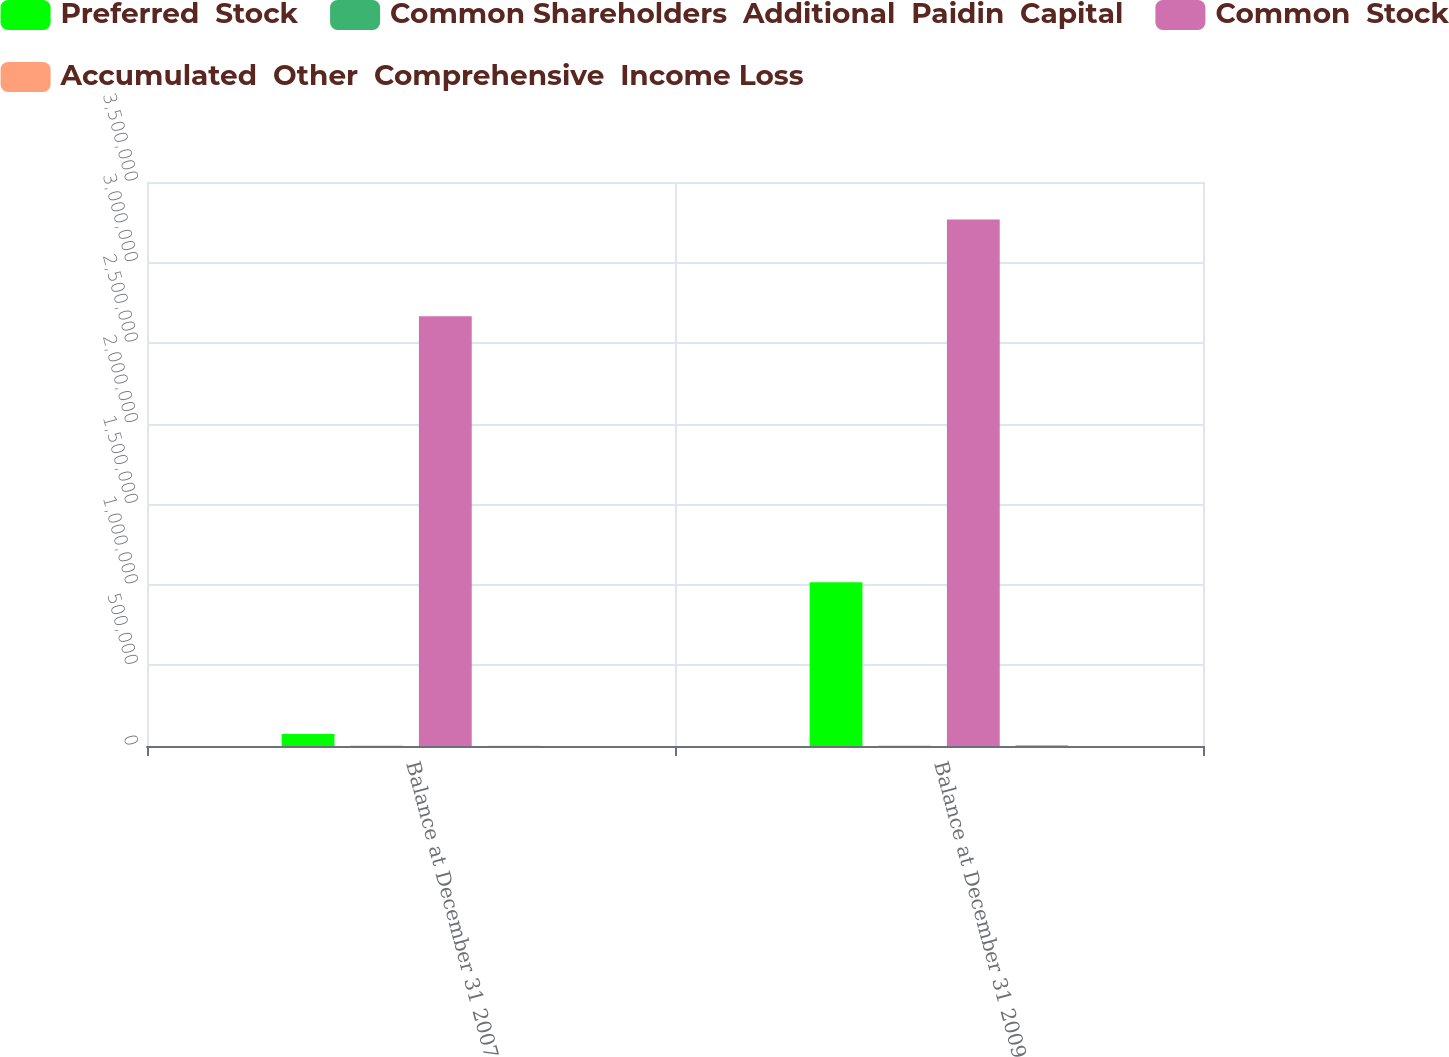<chart> <loc_0><loc_0><loc_500><loc_500><stacked_bar_chart><ecel><fcel>Balance at December 31 2007<fcel>Balance at December 31 2009<nl><fcel>Preferred  Stock<fcel>74400<fcel>1.01662e+06<nl><fcel>Common Shareholders  Additional  Paidin  Capital<fcel>1462<fcel>2240<nl><fcel>Common  Stock<fcel>2.66729e+06<fcel>3.2672e+06<nl><fcel>Accumulated  Other  Comprehensive  Income Loss<fcel>1279<fcel>5630<nl></chart> 